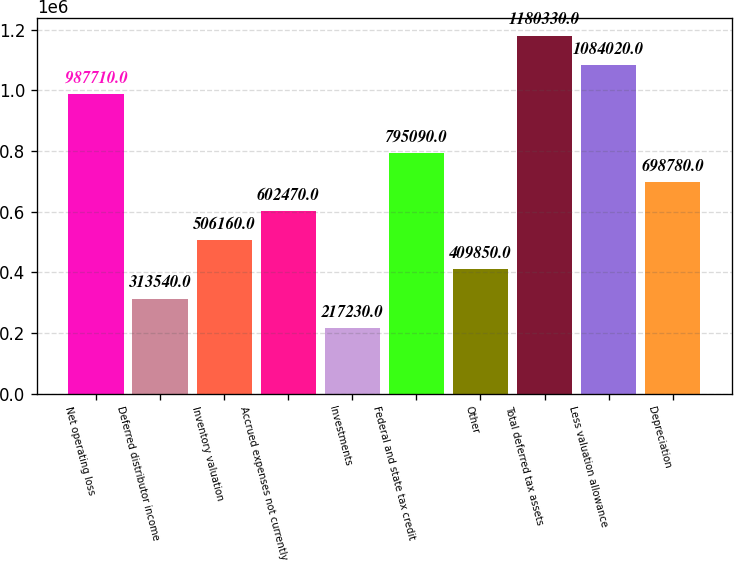Convert chart. <chart><loc_0><loc_0><loc_500><loc_500><bar_chart><fcel>Net operating loss<fcel>Deferred distributor income<fcel>Inventory valuation<fcel>Accrued expenses not currently<fcel>Investments<fcel>Federal and state tax credit<fcel>Other<fcel>Total deferred tax assets<fcel>Less valuation allowance<fcel>Depreciation<nl><fcel>987710<fcel>313540<fcel>506160<fcel>602470<fcel>217230<fcel>795090<fcel>409850<fcel>1.18033e+06<fcel>1.08402e+06<fcel>698780<nl></chart> 